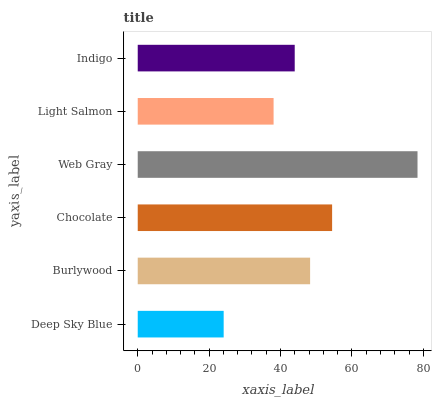Is Deep Sky Blue the minimum?
Answer yes or no. Yes. Is Web Gray the maximum?
Answer yes or no. Yes. Is Burlywood the minimum?
Answer yes or no. No. Is Burlywood the maximum?
Answer yes or no. No. Is Burlywood greater than Deep Sky Blue?
Answer yes or no. Yes. Is Deep Sky Blue less than Burlywood?
Answer yes or no. Yes. Is Deep Sky Blue greater than Burlywood?
Answer yes or no. No. Is Burlywood less than Deep Sky Blue?
Answer yes or no. No. Is Burlywood the high median?
Answer yes or no. Yes. Is Indigo the low median?
Answer yes or no. Yes. Is Chocolate the high median?
Answer yes or no. No. Is Chocolate the low median?
Answer yes or no. No. 